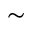<formula> <loc_0><loc_0><loc_500><loc_500>\sim</formula> 